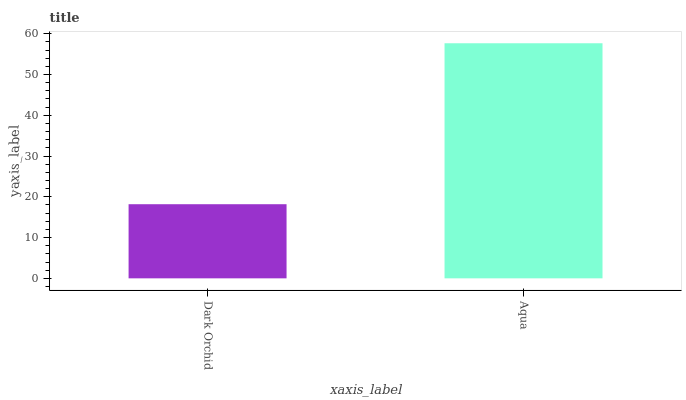Is Dark Orchid the minimum?
Answer yes or no. Yes. Is Aqua the maximum?
Answer yes or no. Yes. Is Aqua the minimum?
Answer yes or no. No. Is Aqua greater than Dark Orchid?
Answer yes or no. Yes. Is Dark Orchid less than Aqua?
Answer yes or no. Yes. Is Dark Orchid greater than Aqua?
Answer yes or no. No. Is Aqua less than Dark Orchid?
Answer yes or no. No. Is Aqua the high median?
Answer yes or no. Yes. Is Dark Orchid the low median?
Answer yes or no. Yes. Is Dark Orchid the high median?
Answer yes or no. No. Is Aqua the low median?
Answer yes or no. No. 